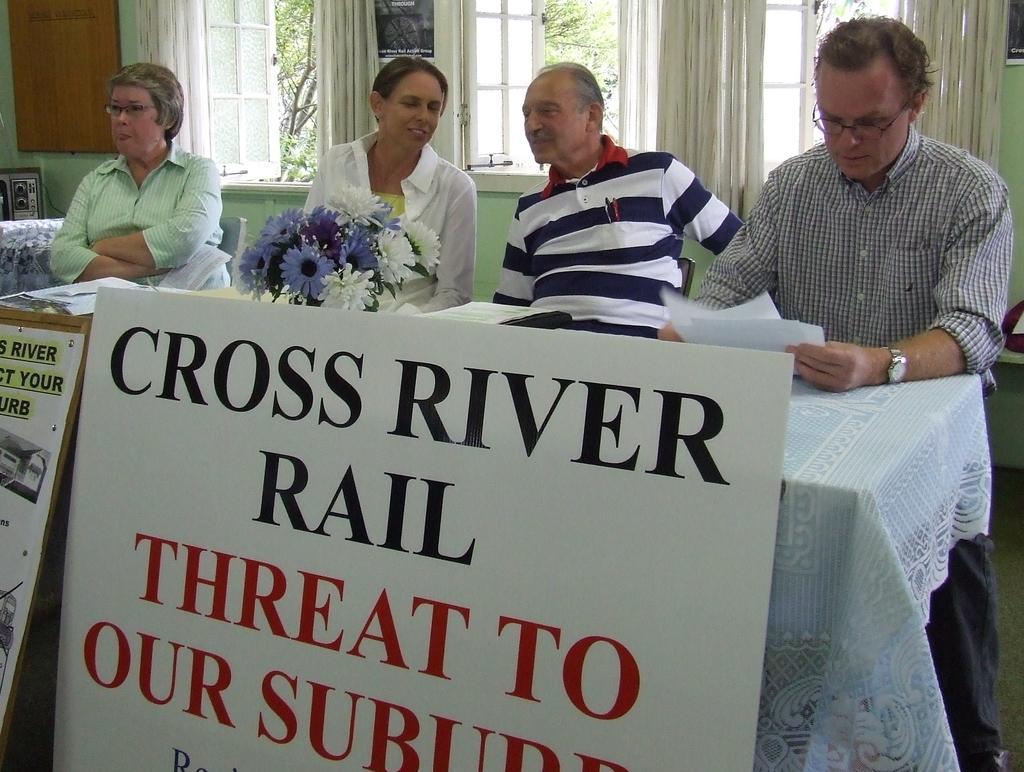Could you give a brief overview of what you see in this image? In this image we can see persons sitting at the table. On the table we can see flower vase and papers. At the bottom of the image we can see boards. In the background we can see windows, wall, curtains and trees. 